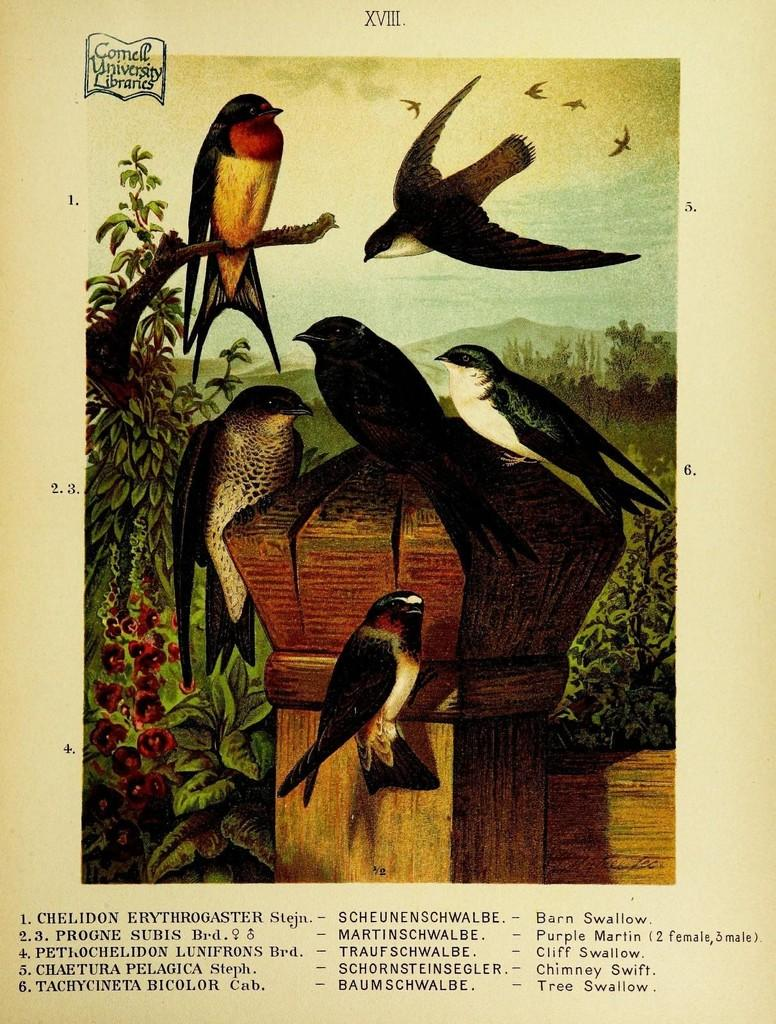What type of animals are depicted in the pictures on the page? The page contains pictures of birds. What additional details can be found on the page? There is information mentioned below the pictures. How many cents are visible in the pictures of birds on the page? There are no cents visible in the pictures of birds on the page, as the images depict birds and not currency. 